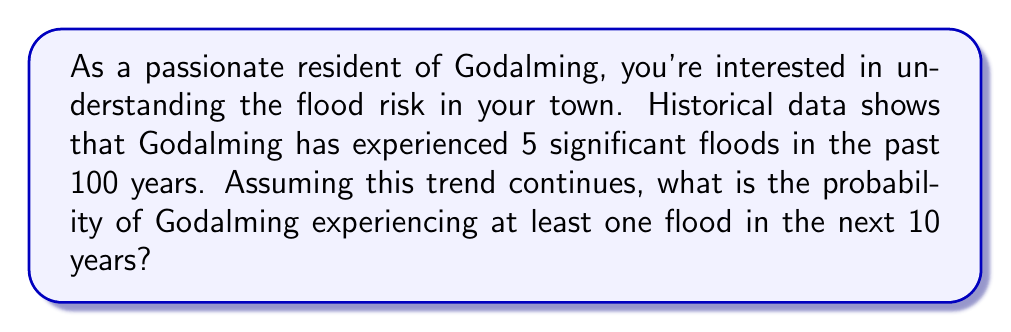Can you answer this question? To solve this problem, we'll use the concept of probability and the given historical data. Let's approach this step-by-step:

1) First, let's calculate the probability of a flood occurring in any given year:
   
   $P(\text{flood in one year}) = \frac{\text{Number of floods}}{\text{Number of years}} = \frac{5}{100} = 0.05$ or 5%

2) Now, we need to find the probability of at least one flood in 10 years. It's often easier to calculate the probability of the complement event (no floods in 10 years) and then subtract from 1.

3) The probability of no flood in one year is:
   
   $P(\text{no flood in one year}) = 1 - P(\text{flood in one year}) = 1 - 0.05 = 0.95$ or 95%

4) For no floods to occur in 10 years, we need this to happen 10 times in a row. Assuming independence, we multiply these probabilities:

   $P(\text{no floods in 10 years}) = (0.95)^{10} \approx 0.5987$

5) Therefore, the probability of at least one flood in 10 years is:

   $P(\text{at least one flood in 10 years}) = 1 - P(\text{no floods in 10 years})$
   $= 1 - 0.5987 \approx 0.4013$

Thus, the probability of Godalming experiencing at least one flood in the next 10 years is approximately 0.4013 or 40.13%.
Answer: The probability of Godalming experiencing at least one flood in the next 10 years is approximately 0.4013 or 40.13%. 